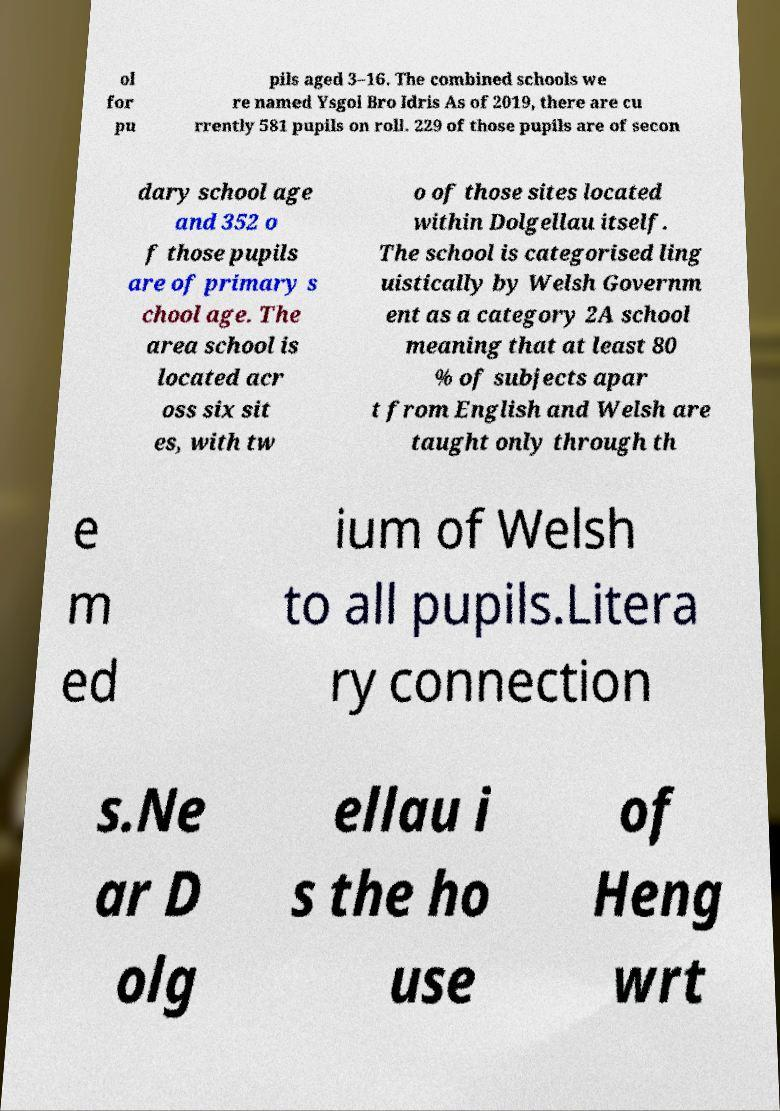Can you accurately transcribe the text from the provided image for me? ol for pu pils aged 3–16. The combined schools we re named Ysgol Bro Idris As of 2019, there are cu rrently 581 pupils on roll. 229 of those pupils are of secon dary school age and 352 o f those pupils are of primary s chool age. The area school is located acr oss six sit es, with tw o of those sites located within Dolgellau itself. The school is categorised ling uistically by Welsh Governm ent as a category 2A school meaning that at least 80 % of subjects apar t from English and Welsh are taught only through th e m ed ium of Welsh to all pupils.Litera ry connection s.Ne ar D olg ellau i s the ho use of Heng wrt 